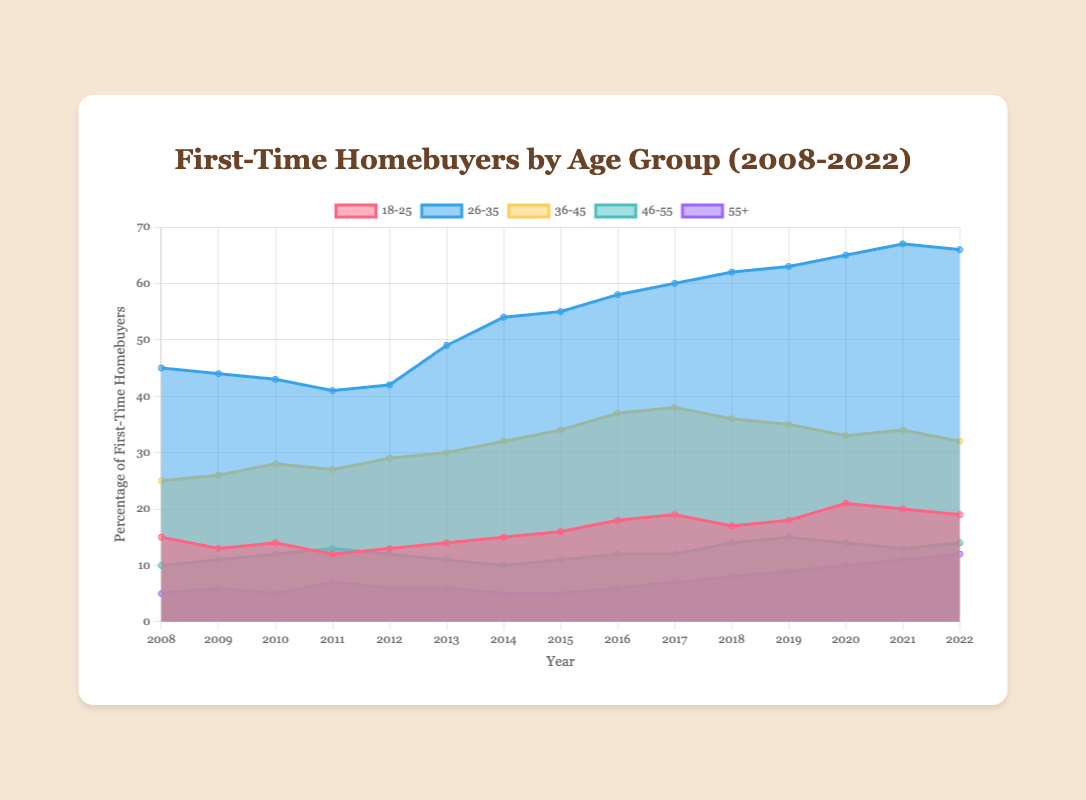what is the title of the figure? The title of the figure is clearly displayed at the top of the chart. It reads "First-Time Homebuyers by Age Group (2008-2022)"
Answer: First-Time Homebuyers by Age Group (2008-2022) Which age group had the highest percentage of first-time homebuyers in 2021? By examining the 2021 data points, we see that the 26-35 age group reaches the highest percentage when compared to other age groups
Answer: 26-35 How did the percentage of first-time homebuyers in the 36-45 age group change from 2008 to 2022? Viewing the data for the 36-45 age group, we see the values increase from 25 in 2008 to a peak and then decrease to 32 in 2022
Answer: Slight increase What is the overall trend for the 55+ age group over the 15 years? The data for the 55+ age group starts from 5 in 2008 and increases steadily each year until it reaches 12 in 2022. This shows a general upward trend
Answer: Upward trend Which year had the lowest percentage of first-time homebuyers in the 18-25 age group? Looking at the data points for the 18-25 age group across all the years, 2011 shows the lowest value at 12
Answer: 2011 In which years did the percentage of first-time homebuyers in the 26-35 age group surpass 60%? Checking the values for the 26-35 age group across the years, 2017, 2018, 2019, 2020, 2021, and 2022 all have percentages over 60%
Answer: 2017, 2018, 2019, 2020, 2021, 2022 How many age groups show an increasing trend from 2008 to 2022? Observing each age group's data, 26-35 and 55+ show a general increase, while others don't consistently increase over the years
Answer: 2 What is the average percentage of first-time homebuyers for the 46-55 age group from 2008 to 2022? Summing up the percentages (10+11+12+13+12+11+10+11+12+12+14+15+14+13+14 = 174) and dividing by 15 years gives 174/15
Answer: 11.6 